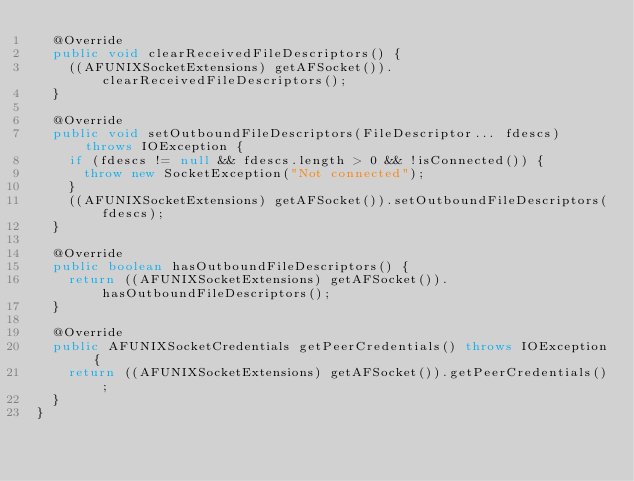Convert code to text. <code><loc_0><loc_0><loc_500><loc_500><_Java_>  @Override
  public void clearReceivedFileDescriptors() {
    ((AFUNIXSocketExtensions) getAFSocket()).clearReceivedFileDescriptors();
  }

  @Override
  public void setOutboundFileDescriptors(FileDescriptor... fdescs) throws IOException {
    if (fdescs != null && fdescs.length > 0 && !isConnected()) {
      throw new SocketException("Not connected");
    }
    ((AFUNIXSocketExtensions) getAFSocket()).setOutboundFileDescriptors(fdescs);
  }

  @Override
  public boolean hasOutboundFileDescriptors() {
    return ((AFUNIXSocketExtensions) getAFSocket()).hasOutboundFileDescriptors();
  }

  @Override
  public AFUNIXSocketCredentials getPeerCredentials() throws IOException {
    return ((AFUNIXSocketExtensions) getAFSocket()).getPeerCredentials();
  }
}
</code> 